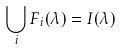<formula> <loc_0><loc_0><loc_500><loc_500>\bigcup _ { i } F _ { i } ( \lambda ) = I ( \lambda )</formula> 